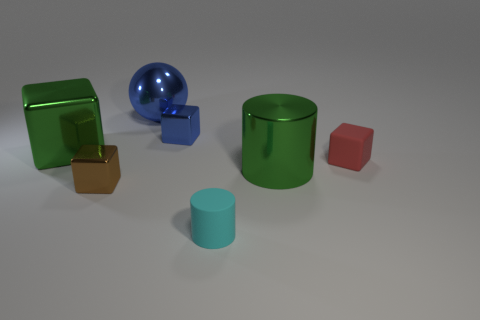What is the size of the blue metallic thing to the right of the blue sphere?
Give a very brief answer. Small. What number of balls are the same size as the shiny cylinder?
Ensure brevity in your answer.  1. Does the green cylinder have the same size as the cylinder that is in front of the small brown cube?
Keep it short and to the point. No. How many objects are cyan cylinders or large purple metal objects?
Keep it short and to the point. 1. What number of metal blocks have the same color as the large ball?
Your response must be concise. 1. What shape is the blue metal object that is the same size as the green cylinder?
Your answer should be compact. Sphere. Are there any red things of the same shape as the cyan object?
Offer a terse response. No. What number of cyan cylinders are the same material as the green block?
Your answer should be very brief. 0. Do the big green thing that is to the left of the metallic cylinder and the tiny red block have the same material?
Offer a terse response. No. Are there more green shiny blocks in front of the blue ball than big metallic objects that are on the left side of the brown thing?
Provide a succinct answer. No. 